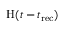<formula> <loc_0><loc_0><loc_500><loc_500>H ( t - t _ { r e c } )</formula> 